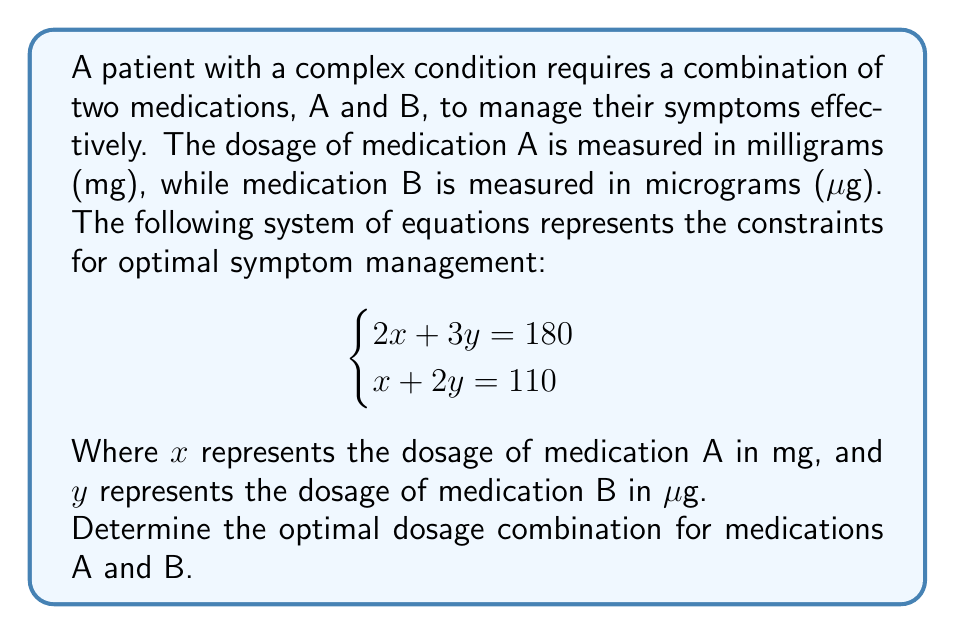Can you solve this math problem? To solve this system of equations, we'll use the substitution method:

1) From the second equation, express $x$ in terms of $y$:
   $x + 2y = 110$
   $x = 110 - 2y$

2) Substitute this expression for $x$ into the first equation:
   $2(110 - 2y) + 3y = 180$

3) Simplify:
   $220 - 4y + 3y = 180$
   $220 - y = 180$

4) Solve for $y$:
   $-y = -40$
   $y = 40$

5) Substitute this value of $y$ back into the equation from step 1 to find $x$:
   $x = 110 - 2(40) = 110 - 80 = 30$

6) Check the solution in both original equations:
   Equation 1: $2(30) + 3(40) = 60 + 120 = 180$ ✓
   Equation 2: $30 + 2(40) = 30 + 80 = 110$ ✓

Therefore, the optimal dosage combination is 30 mg of medication A and 40 μg of medication B.
Answer: $x = 30$ mg, $y = 40$ μg 